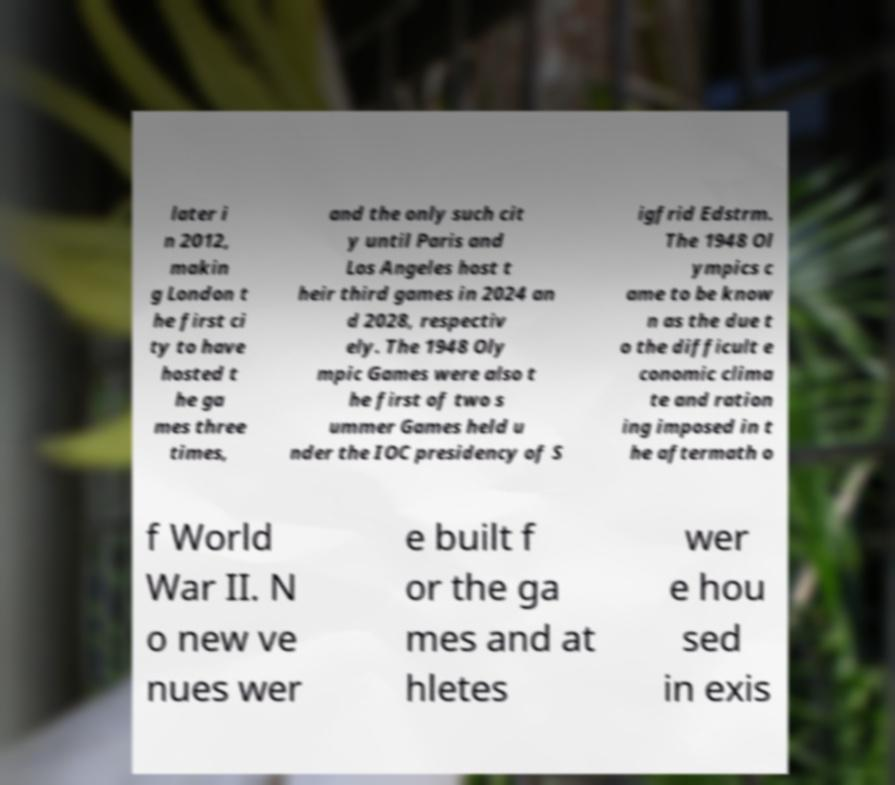Please identify and transcribe the text found in this image. later i n 2012, makin g London t he first ci ty to have hosted t he ga mes three times, and the only such cit y until Paris and Los Angeles host t heir third games in 2024 an d 2028, respectiv ely. The 1948 Oly mpic Games were also t he first of two s ummer Games held u nder the IOC presidency of S igfrid Edstrm. The 1948 Ol ympics c ame to be know n as the due t o the difficult e conomic clima te and ration ing imposed in t he aftermath o f World War II. N o new ve nues wer e built f or the ga mes and at hletes wer e hou sed in exis 